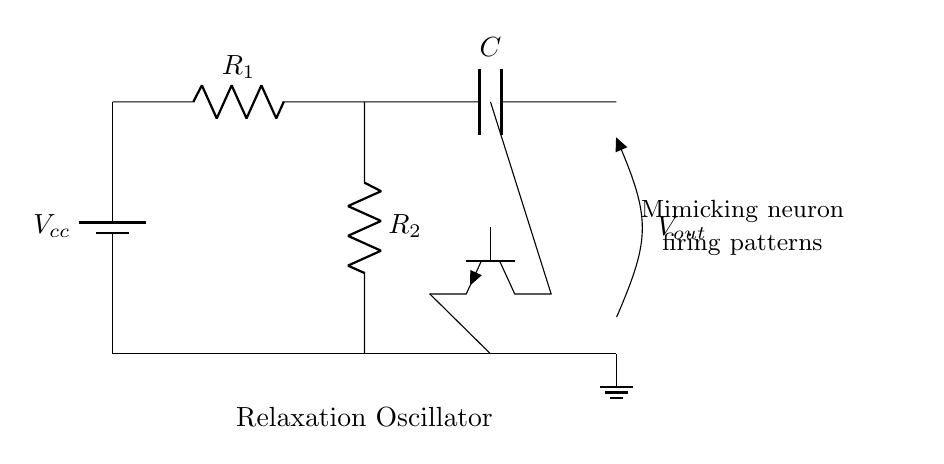What is the voltage source used in this circuit? The circuit includes a battery labeled \( V_{cc} \) indicating it serves as the voltage source.
Answer: Vcc How many resistors are present in the circuit? The circuit diagram shows two resistors labeled \( R_1 \) and \( R_2 \), indicating that there are two resistors in total.
Answer: 2 What component is responsible for the oscillation in this circuit? The transistor, specifically the npn transistor in the circuit, plays a crucial role in generating the oscillation through its switching behavior.
Answer: Transistor What type of capacitor is shown in the circuit? The circuit diagram features a capacitor labeled \( C \), but it does not specify the type, just its identification as \( C \).
Answer: C How does the output relate to the input in terms of firing patterns? The output voltage \( V_{out} \) is influenced by the charging and discharging characteristics of the capacitor in conjunction with the resistors, mimicking the repetitive firing of neurons, indicative of relaxation oscillators.
Answer: Mimics neuron firing What is the primary function of the relaxation oscillator in this circuit? The relaxation oscillator in this circuit is designed to produce repetitive voltage spikes, which simulate the action potential and firing patterns found in neurons.
Answer: Produce repetitive voltage spikes 